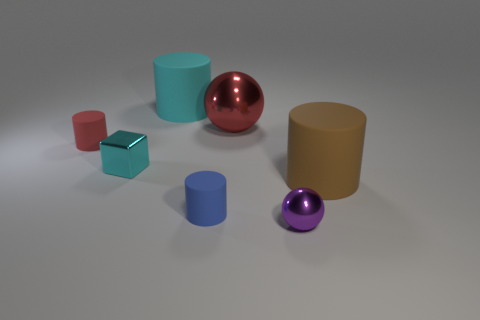Subtract all gray balls. Subtract all yellow blocks. How many balls are left? 2 Subtract all cyan cylinders. How many red spheres are left? 1 Add 3 objects. How many big blues exist? 0 Subtract all large red balls. Subtract all brown matte cylinders. How many objects are left? 5 Add 2 small blue matte things. How many small blue matte things are left? 3 Add 7 big blue rubber blocks. How many big blue rubber blocks exist? 7 Add 2 tiny red matte blocks. How many objects exist? 9 Subtract all blue cylinders. How many cylinders are left? 3 Subtract all small red matte cylinders. How many cylinders are left? 3 Subtract 0 blue balls. How many objects are left? 7 